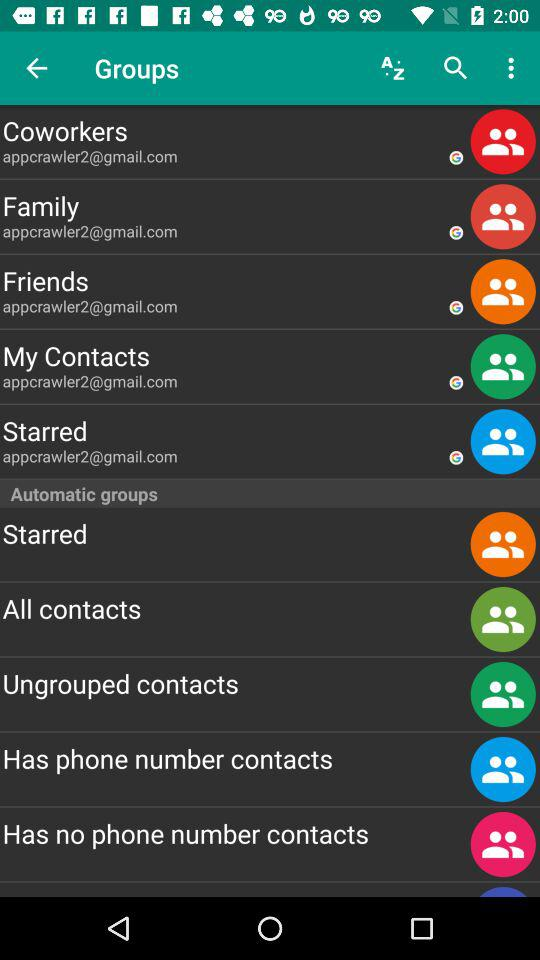What is the email address of the family? The email address of the family is appcrawler2@gmail.com. 